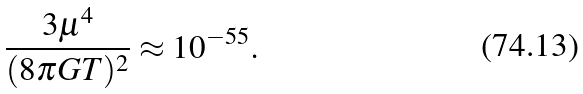Convert formula to latex. <formula><loc_0><loc_0><loc_500><loc_500>\frac { 3 \mu ^ { 4 } } { ( 8 \pi G T ) ^ { 2 } } \approx 1 0 ^ { - 5 5 } .</formula> 